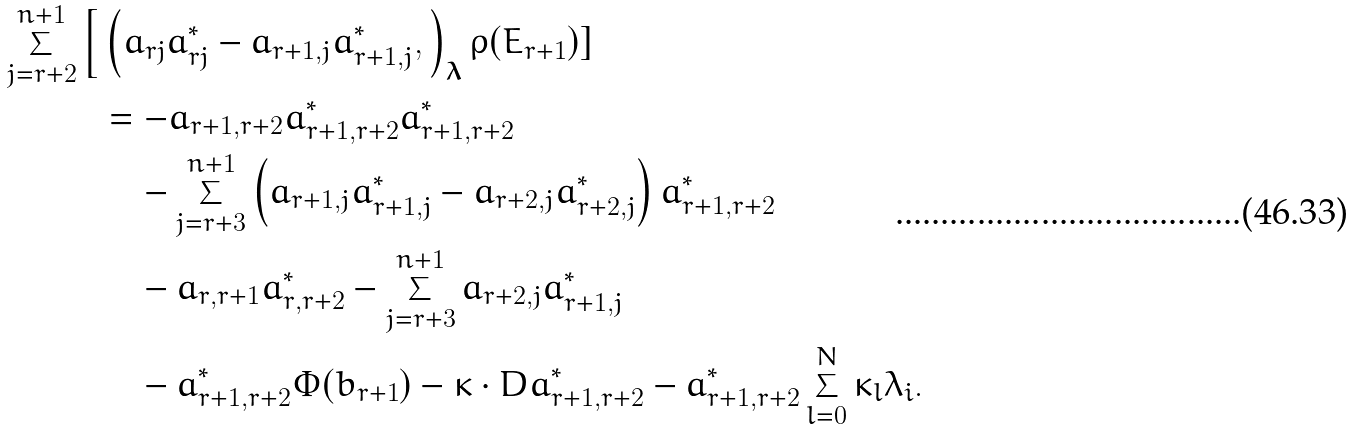<formula> <loc_0><loc_0><loc_500><loc_500>\sum _ { j = r + 2 } ^ { n + 1 } \Big [ & \left ( a _ { r j } a ^ { * } _ { r j } - a _ { r + 1 , j } a ^ { * } _ { r + 1 , j } , \right ) _ { \boldsymbol \lambda } \rho ( E _ { r + 1 } ) ] \\ & = - a _ { r + 1 , r + 2 } a ^ { * } _ { r + 1 , r + 2 } a ^ { * } _ { r + 1 , r + 2 } \\ & \quad - \sum _ { j = r + 3 } ^ { n + 1 } \left ( a _ { r + 1 , j } a ^ { * } _ { r + 1 , j } - a _ { r + 2 , j } a ^ { * } _ { r + 2 , j } \right ) a ^ { * } _ { r + 1 , r + 2 } \\ & \quad - a _ { r , r + 1 } a ^ { * } _ { r , r + 2 } - \sum _ { j = r + 3 } ^ { n + 1 } a _ { r + 2 , j } a ^ { * } _ { r + 1 , j } \\ & \quad - a ^ { * } _ { r + 1 , r + 2 } \Phi ( b _ { r + 1 } ) - \kappa \cdot D a _ { r + 1 , r + 2 } ^ { * } - a _ { r + 1 , r + 2 } ^ { * } \sum _ { l = 0 } ^ { N } \kappa _ { l } \lambda _ { i } .</formula> 